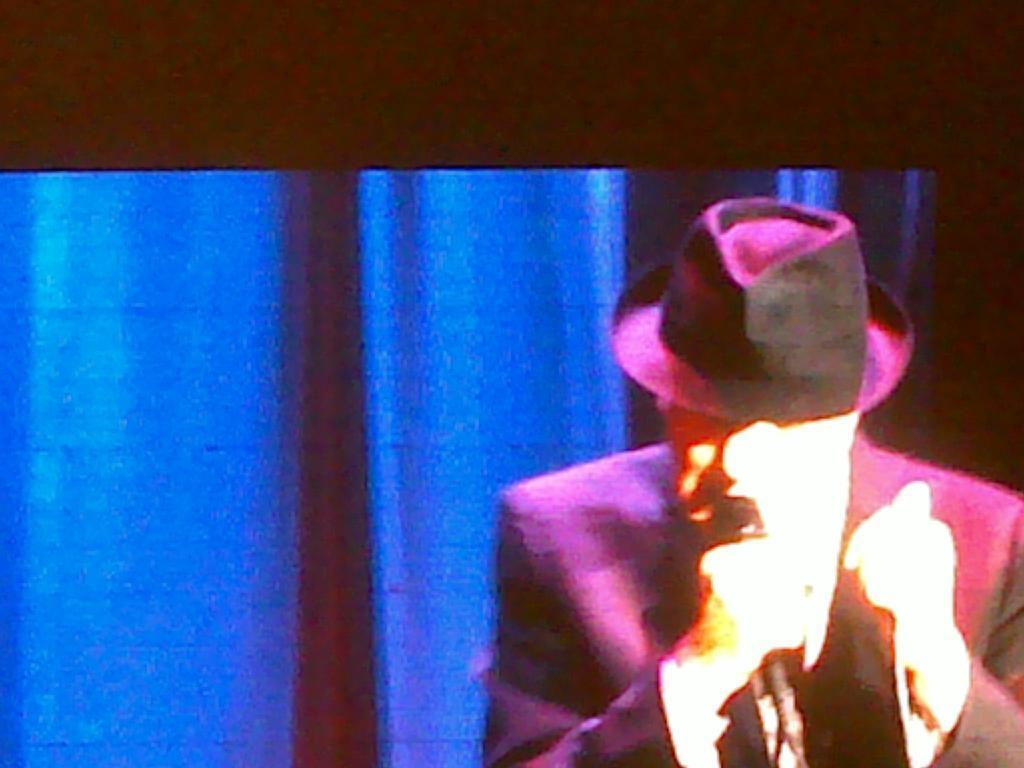Can you describe this image briefly? In this image we can see a screen on which we can see a person wearing cap and holding a microphone in his hand. In the background, we can see curtains. 